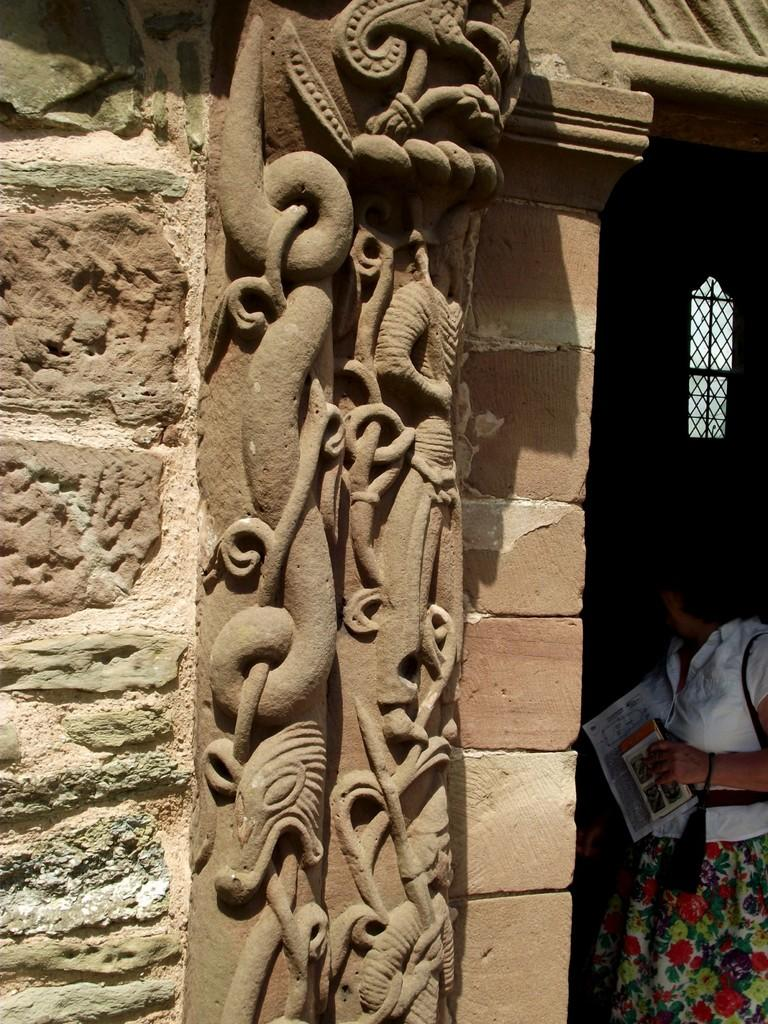What can be seen on the wall in the image? There is art on the wall in the image. What is the woman on the right side of the image holding? The woman is holding a book and paper on the right side of the image. Can you describe the window in the image? There is a window with a grill in the image. Where is the lunchroom located in the image? There is no mention of a lunchroom in the image. Is the woman in the image requesting something from someone? There is no indication in the image that the woman is making a request. 